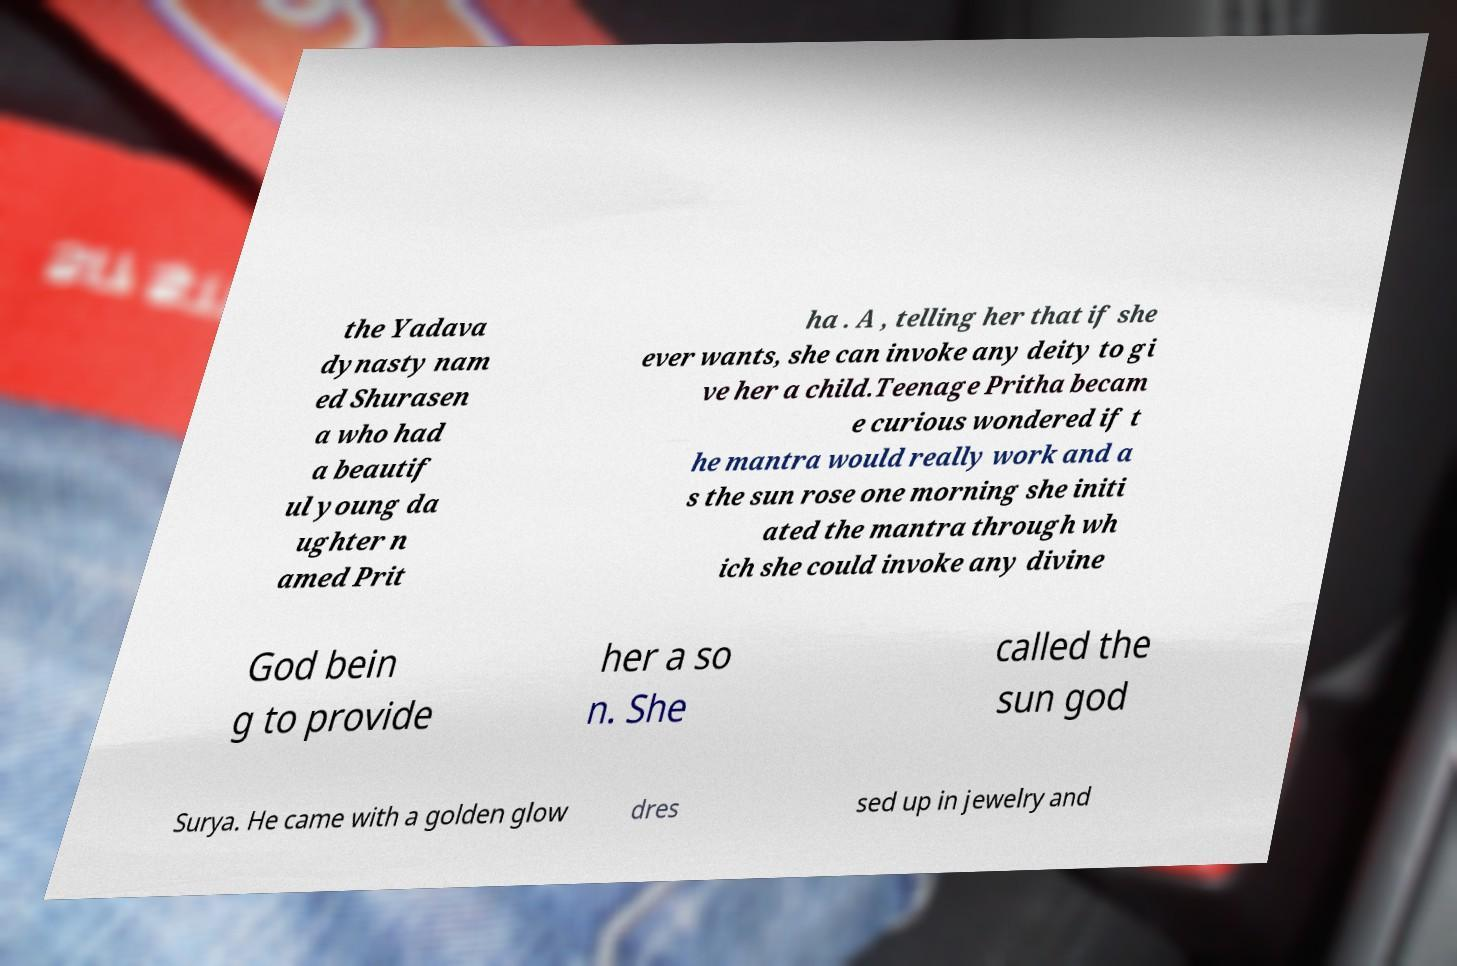There's text embedded in this image that I need extracted. Can you transcribe it verbatim? the Yadava dynasty nam ed Shurasen a who had a beautif ul young da ughter n amed Prit ha . A , telling her that if she ever wants, she can invoke any deity to gi ve her a child.Teenage Pritha becam e curious wondered if t he mantra would really work and a s the sun rose one morning she initi ated the mantra through wh ich she could invoke any divine God bein g to provide her a so n. She called the sun god Surya. He came with a golden glow dres sed up in jewelry and 